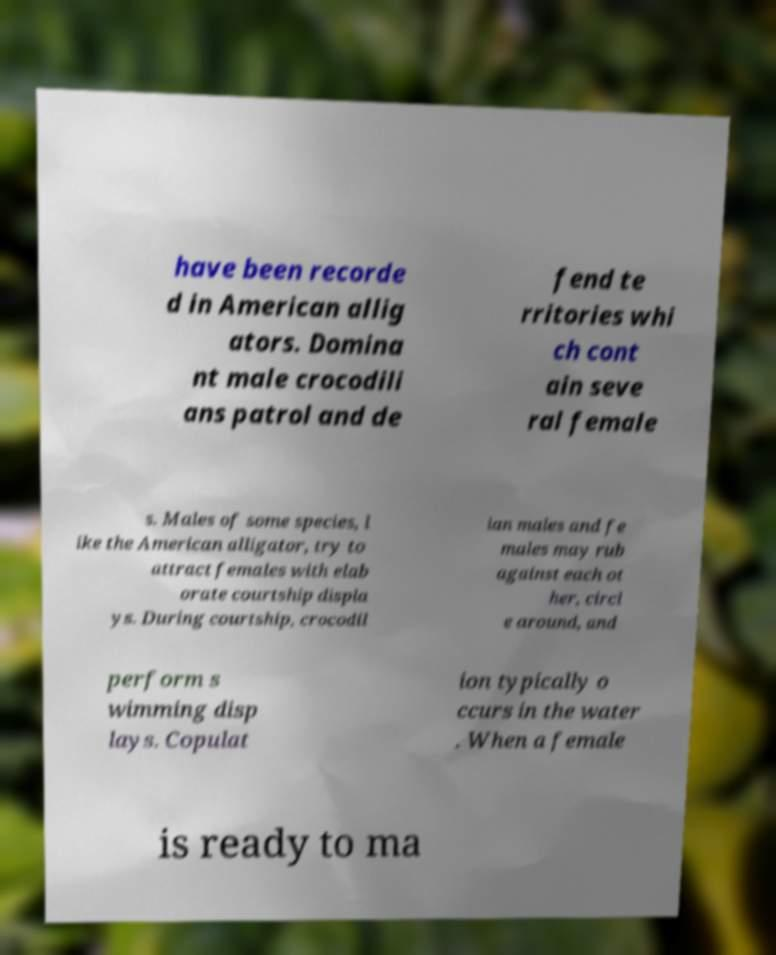There's text embedded in this image that I need extracted. Can you transcribe it verbatim? have been recorde d in American allig ators. Domina nt male crocodili ans patrol and de fend te rritories whi ch cont ain seve ral female s. Males of some species, l ike the American alligator, try to attract females with elab orate courtship displa ys. During courtship, crocodil ian males and fe males may rub against each ot her, circl e around, and perform s wimming disp lays. Copulat ion typically o ccurs in the water . When a female is ready to ma 